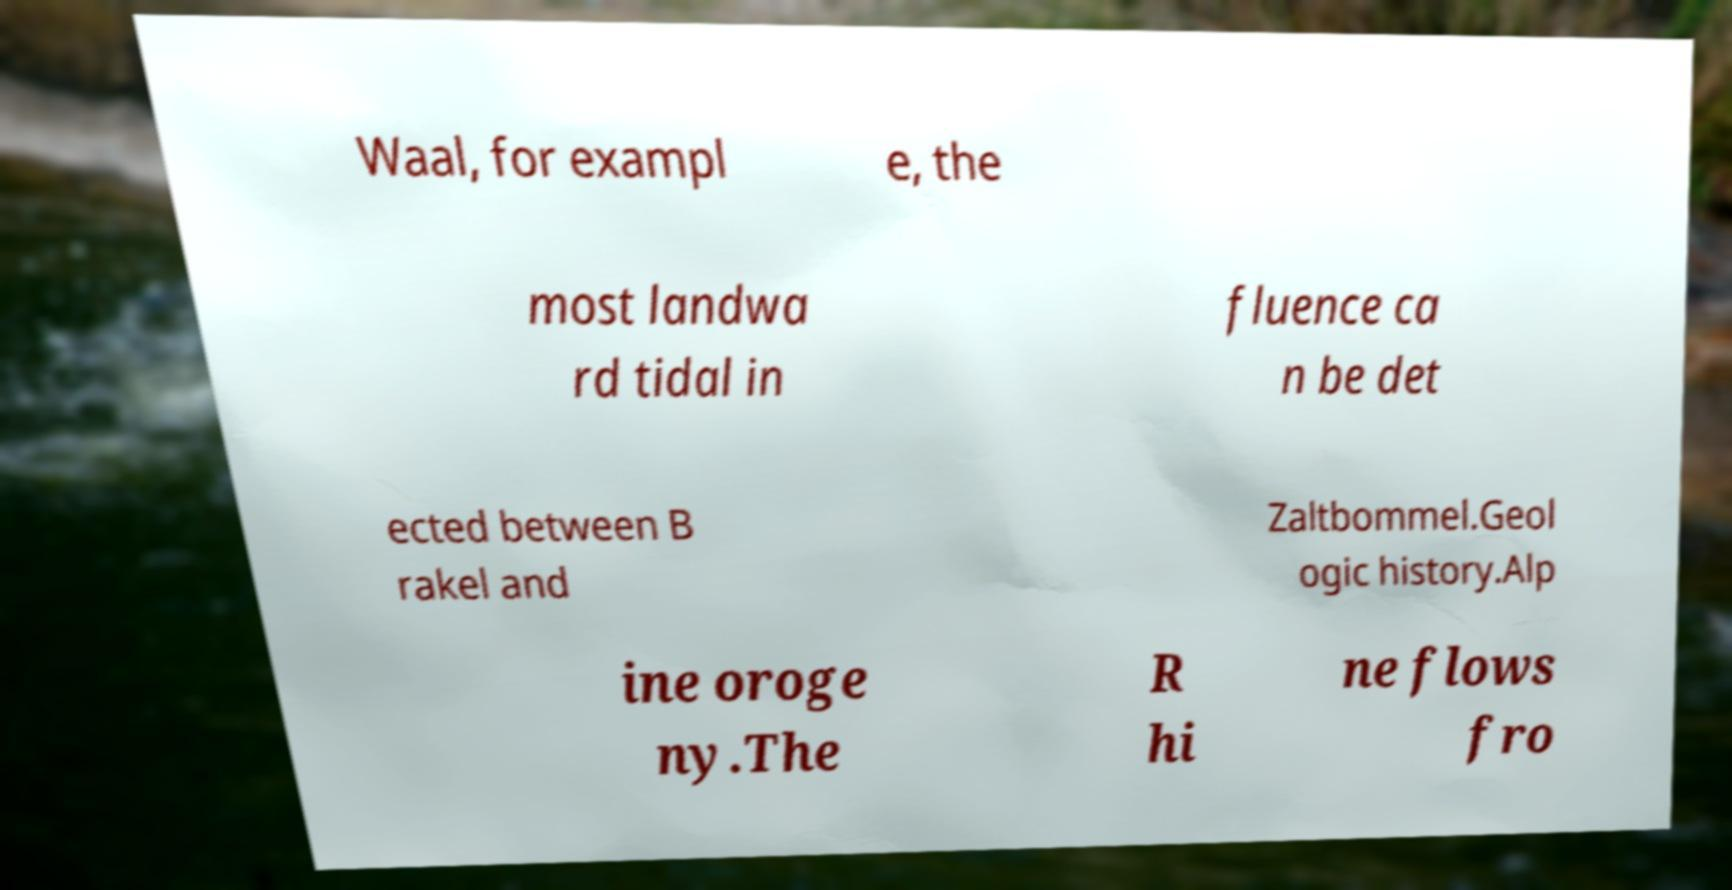Could you assist in decoding the text presented in this image and type it out clearly? Waal, for exampl e, the most landwa rd tidal in fluence ca n be det ected between B rakel and Zaltbommel.Geol ogic history.Alp ine oroge ny.The R hi ne flows fro 